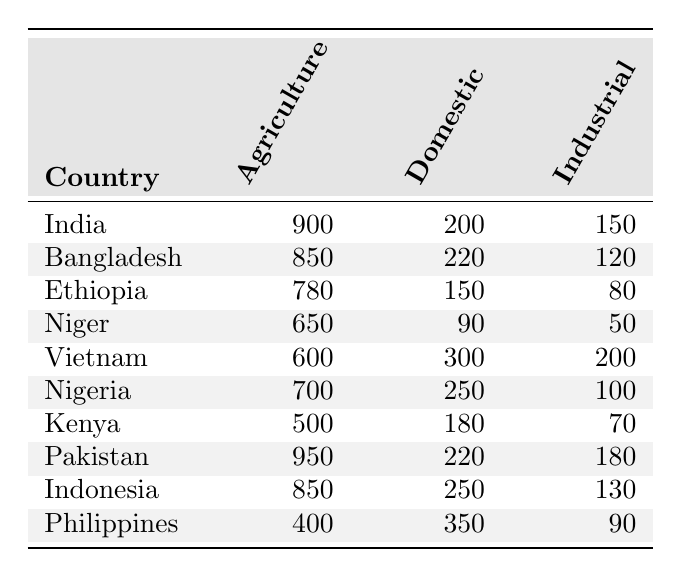What is the highest water usage in agriculture among the listed countries? Looking at the Agriculture column, India has the highest value at 900 units of water usage.
Answer: 900 Which country uses the least amount of water for domestic purposes? By checking the Domestic column, Niger has the lowest value at 90 units of water usage.
Answer: 90 What is the total water usage for industrial purposes by Nigeria and Vietnam? To find the total, add Nigeria’s industrial usage (100) and Vietnam’s industrial usage (200), resulting in 100 + 200 = 300.
Answer: 300 Is it true that Pakistan uses more water for agriculture than Bangladesh? Comparing the Agriculture values, Pakistan uses 950 units while Bangladesh uses 850 units, thus it's true that Pakistan uses more.
Answer: Yes What is the average water usage in domestic sectors across all listed countries? To calculate the average, sum the Domestic values (200 + 220 + 150 + 90 + 300 + 250 + 180 + 220 + 250 + 350 = 2260) then divide by the number of countries (10), therefore 2260 / 10 = 226.
Answer: 226 Which country has the most balanced water usage across all sectors? A possible measure for balance could be the closest values among Agriculture, Domestic, and Industrial. Looking closely, Indonesia has 850, 250, and 130, which are more uniform than others.
Answer: Indonesia How much more water does India use for agriculture compared to Ethiopia? The difference in Agriculture usage is India’s (900) minus Ethiopia’s (780), which equals 900 - 780 = 120.
Answer: 120 What sector has the highest total water usage across all countries? To find this, sum each sector's usage: Agriculture (900 + 850 + 780 + 650 + 600 + 700 + 500 + 950 + 850 + 400 = 8,930), Domestic (200 + 220 + 150 + 90 + 300 + 250 + 180 + 220 + 250 + 350 = 2,210), Industrial (150 + 120 + 80 + 50 + 200 + 100 + 70 + 180 + 130 + 90 = 1,130). Agriculture has the highest total at 8,930.
Answer: Agriculture Which country shows the greatest disparity between domestic and agriculture water usage? The disparity can be assessed by calculating the difference between the Agriculture and Domestic usages for each country and identifying the largest difference. For instance, India has a difference of 900 - 200 = 700, which is the largest.
Answer: India 